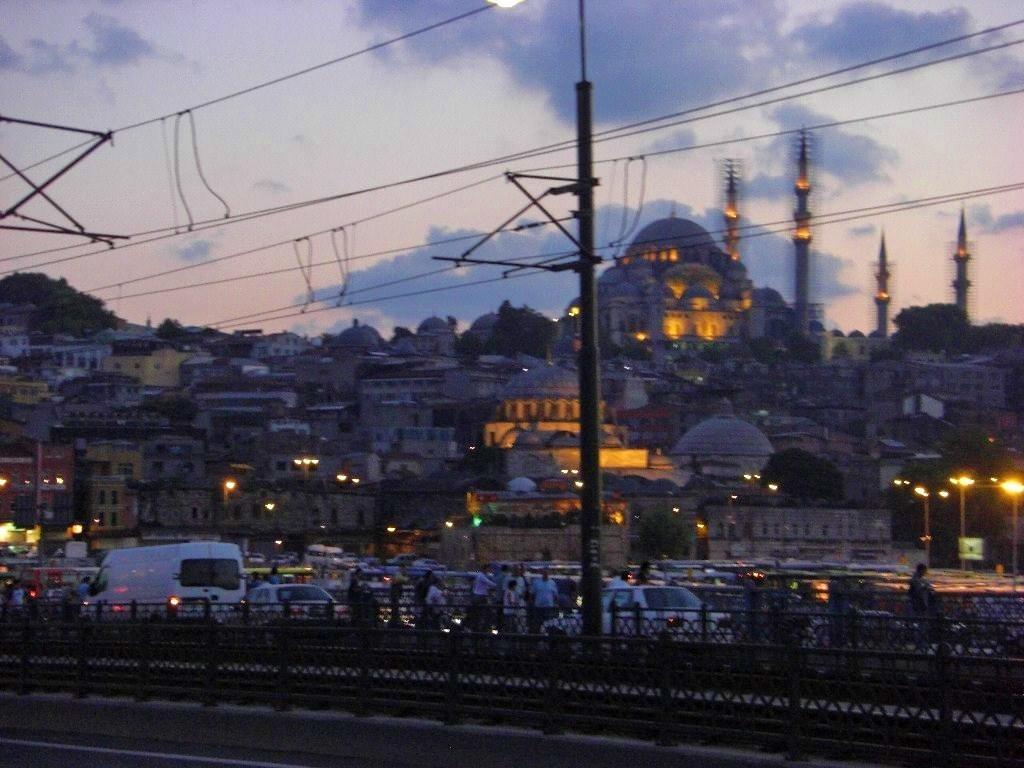How would you summarize this image in a sentence or two? In this picture we can see fence, vehicles and a group of people on the road, buildings with windows, lights, poles, wires, trees and in the background we can see the sky with clouds. 